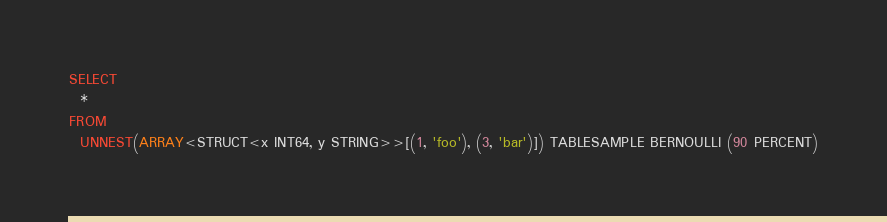Convert code to text. <code><loc_0><loc_0><loc_500><loc_500><_SQL_>SELECT
  *
FROM
  UNNEST(ARRAY<STRUCT<x INT64, y STRING>>[(1, 'foo'), (3, 'bar')]) TABLESAMPLE BERNOULLI (90 PERCENT)
</code> 